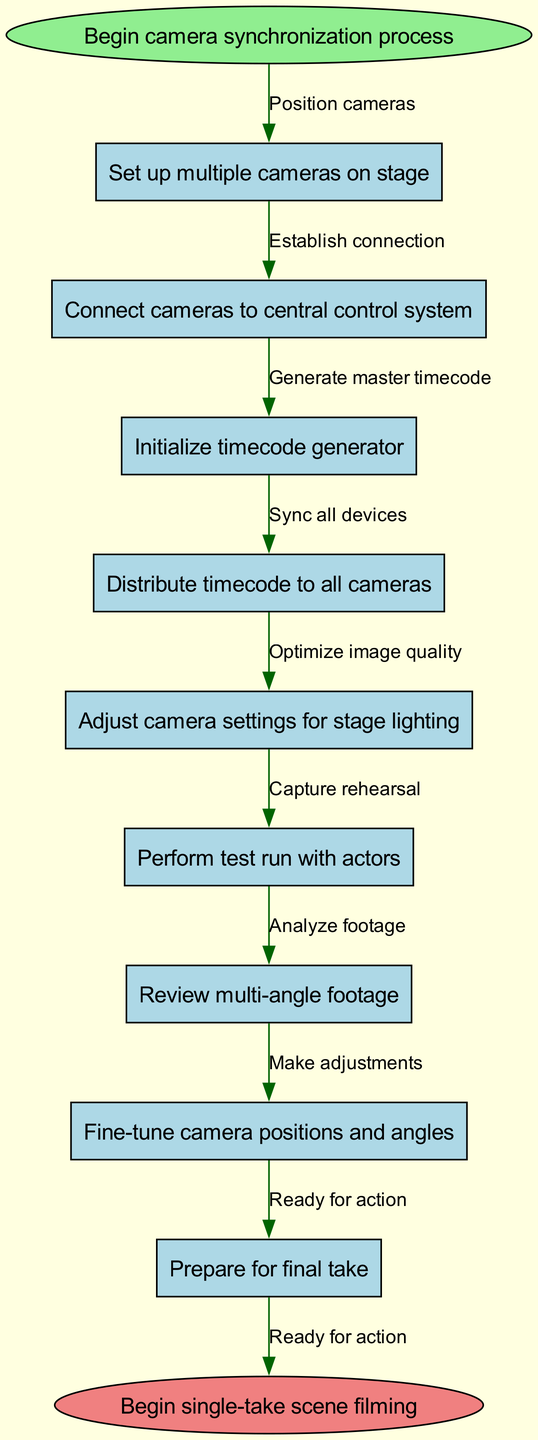What is the first step in the camera synchronization process? The diagram starts with the "Begin camera synchronization process" node, which directs to the next action. Therefore, the first step listed is "Set up multiple cameras on stage."
Answer: Set up multiple cameras on stage How many nodes are present in the diagram? The diagram contains a total of 10 nodes, including the start and end nodes as well as the 8 process nodes in between.
Answer: 10 Which edge connects "Initialize timecode generator" to the next step? The edge connecting "Initialize timecode generator" to the next step is labeled "Generate master timecode." This indicates the action taken after initializing the timecode generator.
Answer: Generate master timecode What is the last process before beginning the final take? According to the flow, the last process listed right before "Begin single-take scene filming" is "Prepare for final take." This is the final preparation step.
Answer: Prepare for final take What relationship exists between "Adjust camera settings for stage lighting" and "Review multi-angle footage"? The edge labeled "Optimize image quality" connects "Adjust camera settings for stage lighting" to "Review multi-angle footage," indicating that after adjustments are made, the footage is reviewed for quality.
Answer: Optimize image quality How many edges are there in the diagram? The diagram shows 9 edges, which include the connections from the start node to the end node through the process nodes.
Answer: 9 What action occurs immediately after "Perform test run with actors"? The next action after "Perform test run with actors" is labeled as "Review multi-angle footage," indicating that reviewing the captured footage is the subsequent step.
Answer: Review multi-angle footage Which node directly follows "Distribute timecode to all cameras"? The node that directly follows "Distribute timecode to all cameras" is "Adjust camera settings for stage lighting." This shows a sequential step in camera synchronization.
Answer: Adjust camera settings for stage lighting What is the purpose of the node "Connect cameras to central control system"? The purpose of the node is to establish a connection between the cameras and the control system, allowing for centralized management during filming.
Answer: Establish connection 